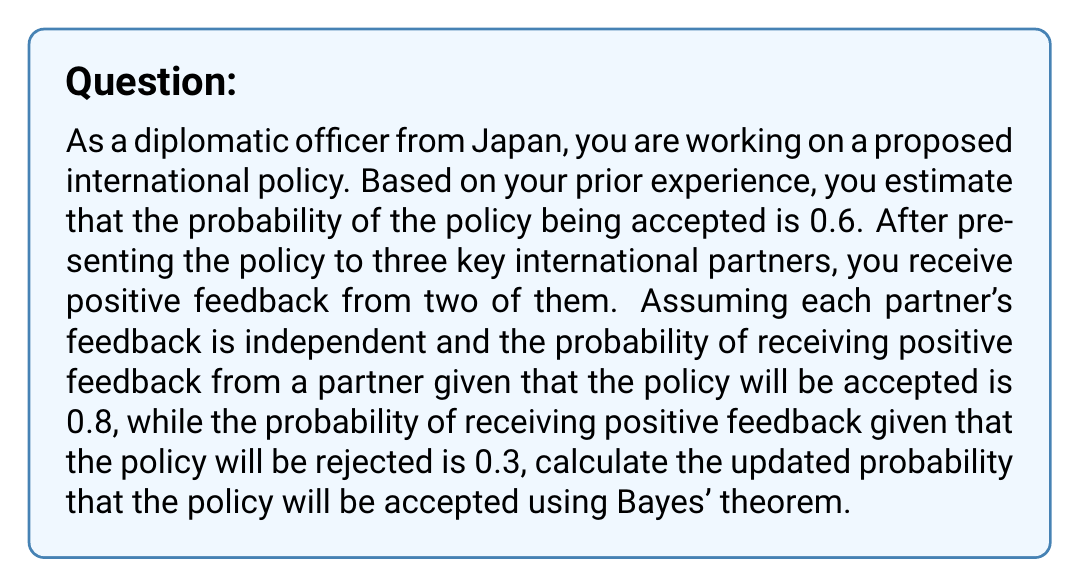Give your solution to this math problem. Let's approach this problem step-by-step using Bayes' theorem:

1. Define the events:
   A: The policy is accepted
   B: Observed feedback (2 positive, 1 negative)

2. Given information:
   P(A) = 0.6 (prior probability of acceptance)
   P(B|A) = 0.8^2 * 0.2^1 (probability of observed feedback given acceptance)
   P(B|not A) = 0.3^2 * 0.7^1 (probability of observed feedback given rejection)

3. Bayes' theorem:
   $$P(A|B) = \frac{P(B|A) \cdot P(A)}{P(B)}$$

4. Calculate P(B|A):
   $$P(B|A) = 0.8^2 \cdot 0.2 = 0.128$$

5. Calculate P(B|not A):
   $$P(B|\text{not }A) = 0.3^2 \cdot 0.7 = 0.063$$

6. Calculate P(B) using the law of total probability:
   $$P(B) = P(B|A) \cdot P(A) + P(B|\text{not }A) \cdot P(\text{not }A)$$
   $$P(B) = 0.128 \cdot 0.6 + 0.063 \cdot 0.4 = 0.0768 + 0.0252 = 0.102$$

7. Apply Bayes' theorem:
   $$P(A|B) = \frac{0.128 \cdot 0.6}{0.102} = \frac{0.0768}{0.102} \approx 0.7529$$

Therefore, the updated probability that the policy will be accepted, given the observed feedback, is approximately 0.7529 or 75.29%.
Answer: 0.7529 (or 75.29%) 